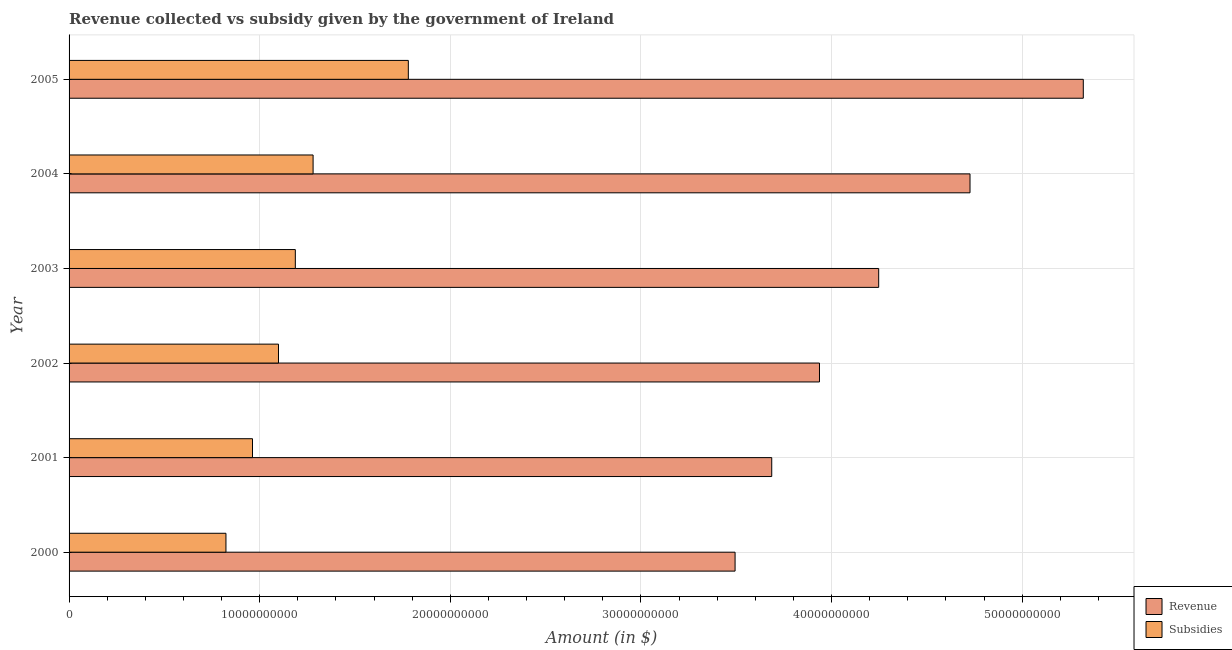How many groups of bars are there?
Offer a terse response. 6. Are the number of bars per tick equal to the number of legend labels?
Make the answer very short. Yes. Are the number of bars on each tick of the Y-axis equal?
Offer a terse response. Yes. How many bars are there on the 4th tick from the top?
Your response must be concise. 2. How many bars are there on the 3rd tick from the bottom?
Your answer should be compact. 2. In how many cases, is the number of bars for a given year not equal to the number of legend labels?
Your answer should be compact. 0. What is the amount of subsidies given in 2002?
Keep it short and to the point. 1.10e+1. Across all years, what is the maximum amount of subsidies given?
Provide a short and direct response. 1.78e+1. Across all years, what is the minimum amount of revenue collected?
Provide a short and direct response. 3.49e+1. What is the total amount of subsidies given in the graph?
Offer a terse response. 7.13e+1. What is the difference between the amount of subsidies given in 2002 and that in 2005?
Offer a terse response. -6.81e+09. What is the difference between the amount of revenue collected in 2000 and the amount of subsidies given in 2005?
Your answer should be very brief. 1.71e+1. What is the average amount of subsidies given per year?
Your answer should be very brief. 1.19e+1. In the year 2001, what is the difference between the amount of revenue collected and amount of subsidies given?
Provide a succinct answer. 2.72e+1. What is the ratio of the amount of subsidies given in 2002 to that in 2005?
Give a very brief answer. 0.62. Is the difference between the amount of revenue collected in 2002 and 2005 greater than the difference between the amount of subsidies given in 2002 and 2005?
Offer a very short reply. No. What is the difference between the highest and the second highest amount of revenue collected?
Provide a short and direct response. 5.94e+09. What is the difference between the highest and the lowest amount of revenue collected?
Provide a succinct answer. 1.83e+1. What does the 2nd bar from the top in 2002 represents?
Offer a terse response. Revenue. What does the 2nd bar from the bottom in 2000 represents?
Your answer should be compact. Subsidies. Are all the bars in the graph horizontal?
Your answer should be very brief. Yes. How many years are there in the graph?
Offer a terse response. 6. What is the difference between two consecutive major ticks on the X-axis?
Your answer should be compact. 1.00e+1. Does the graph contain grids?
Give a very brief answer. Yes. How many legend labels are there?
Make the answer very short. 2. What is the title of the graph?
Give a very brief answer. Revenue collected vs subsidy given by the government of Ireland. Does "Quality of trade" appear as one of the legend labels in the graph?
Provide a succinct answer. No. What is the label or title of the X-axis?
Your answer should be compact. Amount (in $). What is the label or title of the Y-axis?
Your response must be concise. Year. What is the Amount (in $) in Revenue in 2000?
Make the answer very short. 3.49e+1. What is the Amount (in $) of Subsidies in 2000?
Give a very brief answer. 8.23e+09. What is the Amount (in $) in Revenue in 2001?
Ensure brevity in your answer.  3.69e+1. What is the Amount (in $) of Subsidies in 2001?
Your answer should be very brief. 9.62e+09. What is the Amount (in $) of Revenue in 2002?
Make the answer very short. 3.94e+1. What is the Amount (in $) of Subsidies in 2002?
Give a very brief answer. 1.10e+1. What is the Amount (in $) of Revenue in 2003?
Offer a very short reply. 4.25e+1. What is the Amount (in $) in Subsidies in 2003?
Give a very brief answer. 1.19e+1. What is the Amount (in $) in Revenue in 2004?
Your answer should be compact. 4.73e+1. What is the Amount (in $) of Subsidies in 2004?
Provide a short and direct response. 1.28e+1. What is the Amount (in $) of Revenue in 2005?
Provide a succinct answer. 5.32e+1. What is the Amount (in $) in Subsidies in 2005?
Keep it short and to the point. 1.78e+1. Across all years, what is the maximum Amount (in $) of Revenue?
Provide a succinct answer. 5.32e+1. Across all years, what is the maximum Amount (in $) in Subsidies?
Keep it short and to the point. 1.78e+1. Across all years, what is the minimum Amount (in $) of Revenue?
Your answer should be very brief. 3.49e+1. Across all years, what is the minimum Amount (in $) of Subsidies?
Provide a short and direct response. 8.23e+09. What is the total Amount (in $) of Revenue in the graph?
Your answer should be compact. 2.54e+11. What is the total Amount (in $) in Subsidies in the graph?
Your answer should be very brief. 7.13e+1. What is the difference between the Amount (in $) of Revenue in 2000 and that in 2001?
Your answer should be compact. -1.92e+09. What is the difference between the Amount (in $) of Subsidies in 2000 and that in 2001?
Provide a succinct answer. -1.39e+09. What is the difference between the Amount (in $) of Revenue in 2000 and that in 2002?
Offer a very short reply. -4.43e+09. What is the difference between the Amount (in $) of Subsidies in 2000 and that in 2002?
Provide a short and direct response. -2.76e+09. What is the difference between the Amount (in $) in Revenue in 2000 and that in 2003?
Your answer should be very brief. -7.53e+09. What is the difference between the Amount (in $) in Subsidies in 2000 and that in 2003?
Offer a terse response. -3.64e+09. What is the difference between the Amount (in $) of Revenue in 2000 and that in 2004?
Your response must be concise. -1.23e+1. What is the difference between the Amount (in $) in Subsidies in 2000 and that in 2004?
Provide a succinct answer. -4.57e+09. What is the difference between the Amount (in $) of Revenue in 2000 and that in 2005?
Ensure brevity in your answer.  -1.83e+1. What is the difference between the Amount (in $) of Subsidies in 2000 and that in 2005?
Keep it short and to the point. -9.57e+09. What is the difference between the Amount (in $) of Revenue in 2001 and that in 2002?
Give a very brief answer. -2.51e+09. What is the difference between the Amount (in $) in Subsidies in 2001 and that in 2002?
Offer a terse response. -1.36e+09. What is the difference between the Amount (in $) of Revenue in 2001 and that in 2003?
Offer a terse response. -5.61e+09. What is the difference between the Amount (in $) of Subsidies in 2001 and that in 2003?
Ensure brevity in your answer.  -2.25e+09. What is the difference between the Amount (in $) of Revenue in 2001 and that in 2004?
Ensure brevity in your answer.  -1.04e+1. What is the difference between the Amount (in $) in Subsidies in 2001 and that in 2004?
Give a very brief answer. -3.18e+09. What is the difference between the Amount (in $) of Revenue in 2001 and that in 2005?
Keep it short and to the point. -1.63e+1. What is the difference between the Amount (in $) of Subsidies in 2001 and that in 2005?
Offer a terse response. -8.17e+09. What is the difference between the Amount (in $) of Revenue in 2002 and that in 2003?
Your answer should be very brief. -3.11e+09. What is the difference between the Amount (in $) in Subsidies in 2002 and that in 2003?
Provide a succinct answer. -8.83e+08. What is the difference between the Amount (in $) in Revenue in 2002 and that in 2004?
Give a very brief answer. -7.90e+09. What is the difference between the Amount (in $) of Subsidies in 2002 and that in 2004?
Keep it short and to the point. -1.82e+09. What is the difference between the Amount (in $) of Revenue in 2002 and that in 2005?
Your answer should be compact. -1.38e+1. What is the difference between the Amount (in $) in Subsidies in 2002 and that in 2005?
Ensure brevity in your answer.  -6.81e+09. What is the difference between the Amount (in $) in Revenue in 2003 and that in 2004?
Provide a succinct answer. -4.79e+09. What is the difference between the Amount (in $) in Subsidies in 2003 and that in 2004?
Provide a short and direct response. -9.32e+08. What is the difference between the Amount (in $) of Revenue in 2003 and that in 2005?
Offer a very short reply. -1.07e+1. What is the difference between the Amount (in $) of Subsidies in 2003 and that in 2005?
Provide a succinct answer. -5.93e+09. What is the difference between the Amount (in $) in Revenue in 2004 and that in 2005?
Ensure brevity in your answer.  -5.94e+09. What is the difference between the Amount (in $) in Subsidies in 2004 and that in 2005?
Make the answer very short. -5.00e+09. What is the difference between the Amount (in $) of Revenue in 2000 and the Amount (in $) of Subsidies in 2001?
Offer a very short reply. 2.53e+1. What is the difference between the Amount (in $) in Revenue in 2000 and the Amount (in $) in Subsidies in 2002?
Keep it short and to the point. 2.40e+1. What is the difference between the Amount (in $) of Revenue in 2000 and the Amount (in $) of Subsidies in 2003?
Make the answer very short. 2.31e+1. What is the difference between the Amount (in $) of Revenue in 2000 and the Amount (in $) of Subsidies in 2004?
Provide a succinct answer. 2.21e+1. What is the difference between the Amount (in $) of Revenue in 2000 and the Amount (in $) of Subsidies in 2005?
Keep it short and to the point. 1.71e+1. What is the difference between the Amount (in $) in Revenue in 2001 and the Amount (in $) in Subsidies in 2002?
Offer a very short reply. 2.59e+1. What is the difference between the Amount (in $) in Revenue in 2001 and the Amount (in $) in Subsidies in 2003?
Your answer should be very brief. 2.50e+1. What is the difference between the Amount (in $) in Revenue in 2001 and the Amount (in $) in Subsidies in 2004?
Keep it short and to the point. 2.41e+1. What is the difference between the Amount (in $) in Revenue in 2001 and the Amount (in $) in Subsidies in 2005?
Your answer should be very brief. 1.91e+1. What is the difference between the Amount (in $) of Revenue in 2002 and the Amount (in $) of Subsidies in 2003?
Your response must be concise. 2.75e+1. What is the difference between the Amount (in $) of Revenue in 2002 and the Amount (in $) of Subsidies in 2004?
Provide a succinct answer. 2.66e+1. What is the difference between the Amount (in $) of Revenue in 2002 and the Amount (in $) of Subsidies in 2005?
Your answer should be very brief. 2.16e+1. What is the difference between the Amount (in $) in Revenue in 2003 and the Amount (in $) in Subsidies in 2004?
Give a very brief answer. 2.97e+1. What is the difference between the Amount (in $) in Revenue in 2003 and the Amount (in $) in Subsidies in 2005?
Your response must be concise. 2.47e+1. What is the difference between the Amount (in $) of Revenue in 2004 and the Amount (in $) of Subsidies in 2005?
Ensure brevity in your answer.  2.95e+1. What is the average Amount (in $) in Revenue per year?
Provide a succinct answer. 4.24e+1. What is the average Amount (in $) in Subsidies per year?
Your response must be concise. 1.19e+1. In the year 2000, what is the difference between the Amount (in $) of Revenue and Amount (in $) of Subsidies?
Your response must be concise. 2.67e+1. In the year 2001, what is the difference between the Amount (in $) in Revenue and Amount (in $) in Subsidies?
Provide a short and direct response. 2.72e+1. In the year 2002, what is the difference between the Amount (in $) of Revenue and Amount (in $) of Subsidies?
Your answer should be compact. 2.84e+1. In the year 2003, what is the difference between the Amount (in $) in Revenue and Amount (in $) in Subsidies?
Ensure brevity in your answer.  3.06e+1. In the year 2004, what is the difference between the Amount (in $) in Revenue and Amount (in $) in Subsidies?
Your answer should be very brief. 3.45e+1. In the year 2005, what is the difference between the Amount (in $) in Revenue and Amount (in $) in Subsidies?
Make the answer very short. 3.54e+1. What is the ratio of the Amount (in $) of Revenue in 2000 to that in 2001?
Your answer should be very brief. 0.95. What is the ratio of the Amount (in $) of Subsidies in 2000 to that in 2001?
Offer a very short reply. 0.86. What is the ratio of the Amount (in $) in Revenue in 2000 to that in 2002?
Your answer should be very brief. 0.89. What is the ratio of the Amount (in $) of Subsidies in 2000 to that in 2002?
Make the answer very short. 0.75. What is the ratio of the Amount (in $) in Revenue in 2000 to that in 2003?
Offer a very short reply. 0.82. What is the ratio of the Amount (in $) in Subsidies in 2000 to that in 2003?
Ensure brevity in your answer.  0.69. What is the ratio of the Amount (in $) in Revenue in 2000 to that in 2004?
Keep it short and to the point. 0.74. What is the ratio of the Amount (in $) in Subsidies in 2000 to that in 2004?
Provide a short and direct response. 0.64. What is the ratio of the Amount (in $) in Revenue in 2000 to that in 2005?
Give a very brief answer. 0.66. What is the ratio of the Amount (in $) in Subsidies in 2000 to that in 2005?
Give a very brief answer. 0.46. What is the ratio of the Amount (in $) in Revenue in 2001 to that in 2002?
Your answer should be compact. 0.94. What is the ratio of the Amount (in $) in Subsidies in 2001 to that in 2002?
Ensure brevity in your answer.  0.88. What is the ratio of the Amount (in $) of Revenue in 2001 to that in 2003?
Give a very brief answer. 0.87. What is the ratio of the Amount (in $) in Subsidies in 2001 to that in 2003?
Offer a terse response. 0.81. What is the ratio of the Amount (in $) in Revenue in 2001 to that in 2004?
Your answer should be compact. 0.78. What is the ratio of the Amount (in $) of Subsidies in 2001 to that in 2004?
Your answer should be compact. 0.75. What is the ratio of the Amount (in $) in Revenue in 2001 to that in 2005?
Provide a short and direct response. 0.69. What is the ratio of the Amount (in $) of Subsidies in 2001 to that in 2005?
Make the answer very short. 0.54. What is the ratio of the Amount (in $) of Revenue in 2002 to that in 2003?
Your answer should be compact. 0.93. What is the ratio of the Amount (in $) in Subsidies in 2002 to that in 2003?
Your response must be concise. 0.93. What is the ratio of the Amount (in $) in Revenue in 2002 to that in 2004?
Give a very brief answer. 0.83. What is the ratio of the Amount (in $) of Subsidies in 2002 to that in 2004?
Your response must be concise. 0.86. What is the ratio of the Amount (in $) of Revenue in 2002 to that in 2005?
Provide a short and direct response. 0.74. What is the ratio of the Amount (in $) of Subsidies in 2002 to that in 2005?
Keep it short and to the point. 0.62. What is the ratio of the Amount (in $) of Revenue in 2003 to that in 2004?
Offer a very short reply. 0.9. What is the ratio of the Amount (in $) of Subsidies in 2003 to that in 2004?
Make the answer very short. 0.93. What is the ratio of the Amount (in $) of Revenue in 2003 to that in 2005?
Ensure brevity in your answer.  0.8. What is the ratio of the Amount (in $) of Subsidies in 2003 to that in 2005?
Keep it short and to the point. 0.67. What is the ratio of the Amount (in $) in Revenue in 2004 to that in 2005?
Your response must be concise. 0.89. What is the ratio of the Amount (in $) of Subsidies in 2004 to that in 2005?
Offer a terse response. 0.72. What is the difference between the highest and the second highest Amount (in $) of Revenue?
Your answer should be compact. 5.94e+09. What is the difference between the highest and the second highest Amount (in $) of Subsidies?
Your answer should be compact. 5.00e+09. What is the difference between the highest and the lowest Amount (in $) of Revenue?
Keep it short and to the point. 1.83e+1. What is the difference between the highest and the lowest Amount (in $) of Subsidies?
Keep it short and to the point. 9.57e+09. 